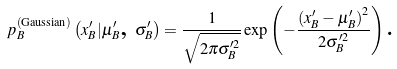Convert formula to latex. <formula><loc_0><loc_0><loc_500><loc_500>p _ { B } ^ { \left ( \text {Gaussian} \right ) } \left ( x _ { B } ^ { \prime } | \mu _ { B } ^ { \prime } \text {, } \sigma _ { B } ^ { \prime } \right ) = \frac { 1 } { \sqrt { 2 \pi \sigma _ { B } ^ { \prime 2 } } } \exp \left ( - \frac { \left ( x _ { B } ^ { \prime } - \mu _ { B } ^ { \prime } \right ) ^ { 2 } } { 2 \sigma _ { B } ^ { \prime 2 } } \right ) \text {.}</formula> 